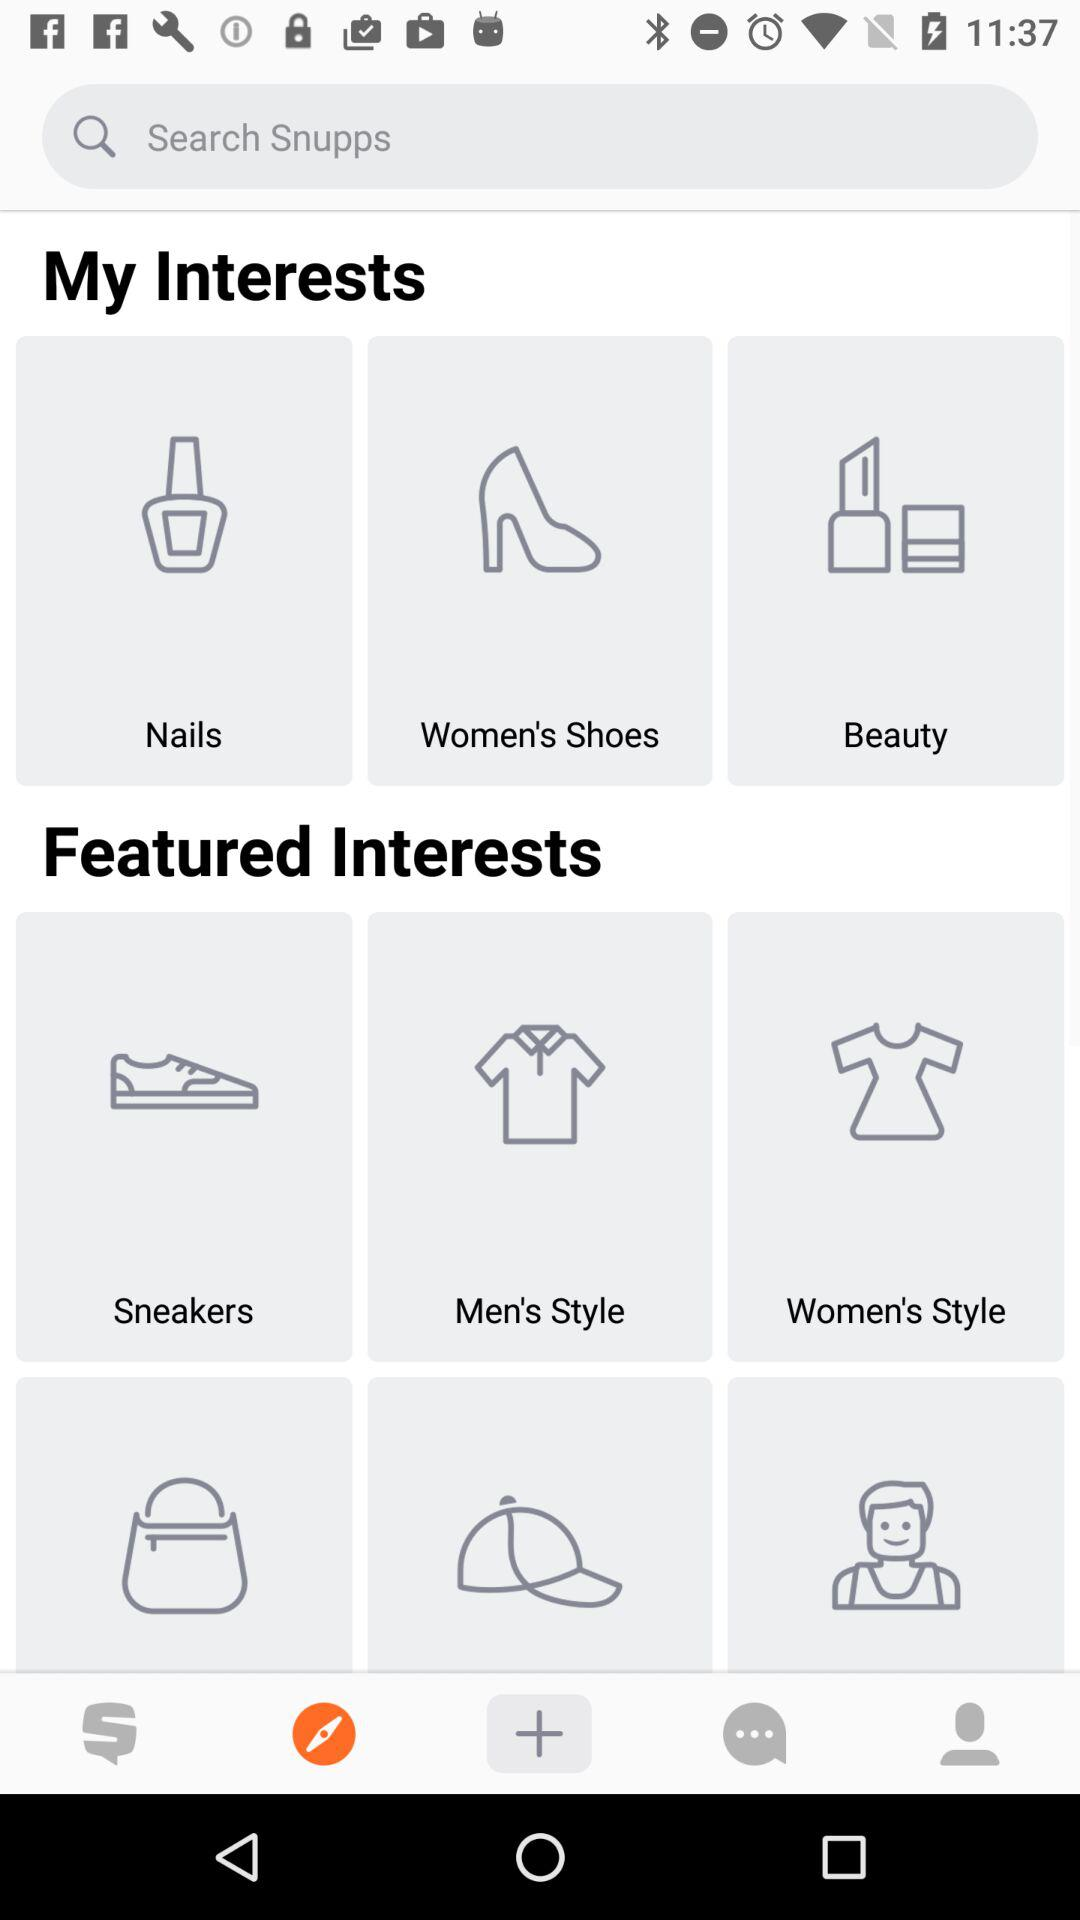How many more items are in the Featured Interests section than the My Interests section?
Answer the question using a single word or phrase. 3 